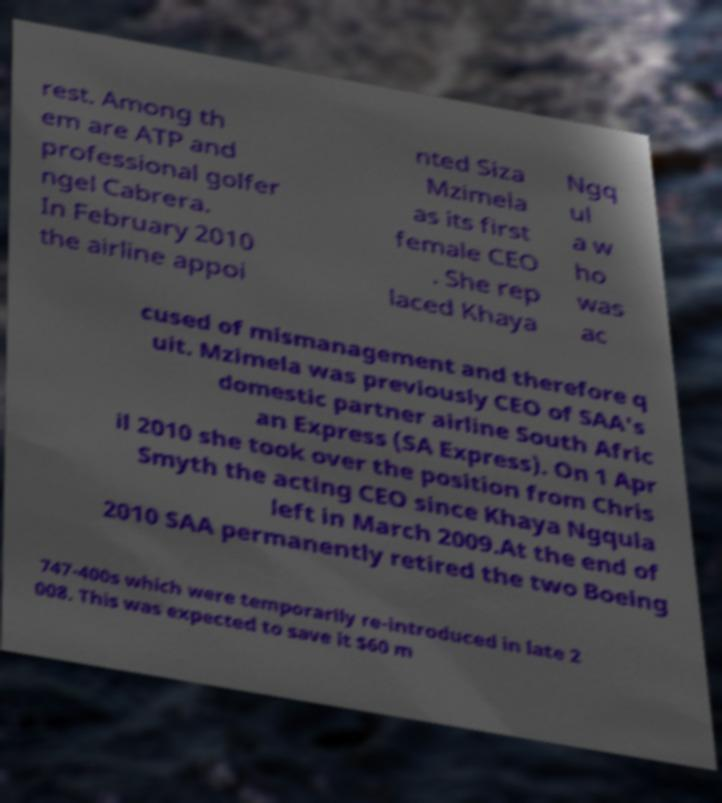What messages or text are displayed in this image? I need them in a readable, typed format. rest. Among th em are ATP and professional golfer ngel Cabrera. In February 2010 the airline appoi nted Siza Mzimela as its first female CEO . She rep laced Khaya Ngq ul a w ho was ac cused of mismanagement and therefore q uit. Mzimela was previously CEO of SAA's domestic partner airline South Afric an Express (SA Express). On 1 Apr il 2010 she took over the position from Chris Smyth the acting CEO since Khaya Ngqula left in March 2009.At the end of 2010 SAA permanently retired the two Boeing 747-400s which were temporarily re-introduced in late 2 008. This was expected to save it $60 m 